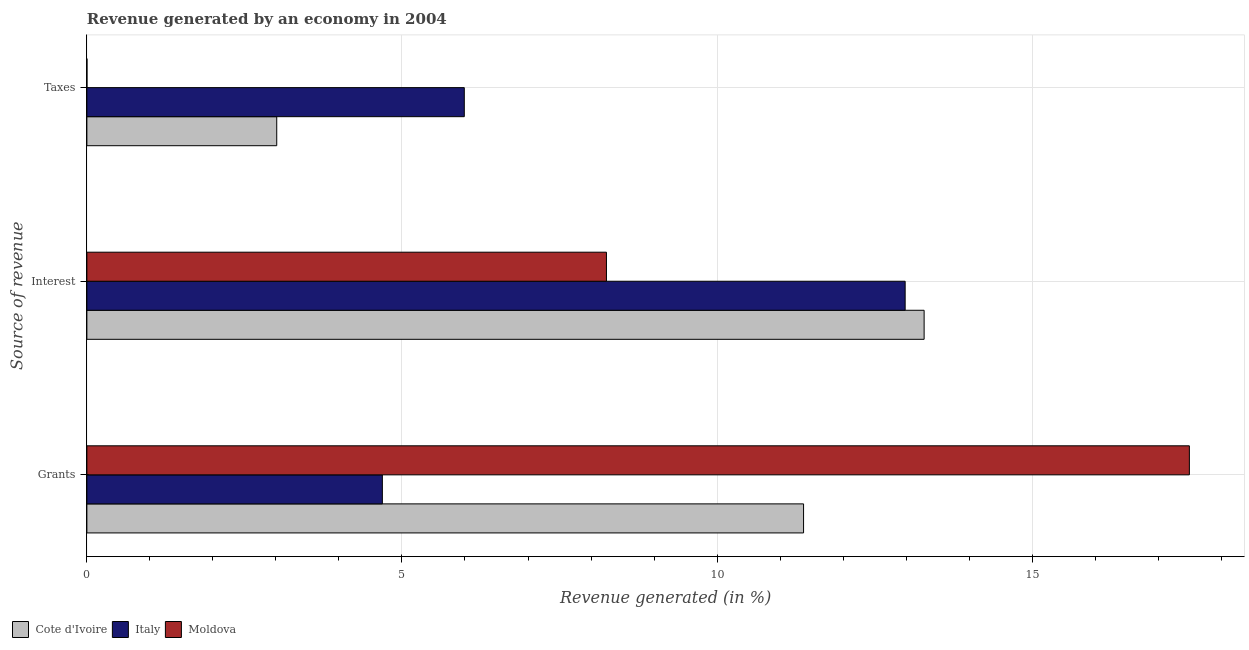How many groups of bars are there?
Your answer should be compact. 3. Are the number of bars per tick equal to the number of legend labels?
Offer a terse response. Yes. How many bars are there on the 2nd tick from the bottom?
Make the answer very short. 3. What is the label of the 1st group of bars from the top?
Your answer should be very brief. Taxes. What is the percentage of revenue generated by interest in Cote d'Ivoire?
Offer a very short reply. 13.29. Across all countries, what is the maximum percentage of revenue generated by interest?
Keep it short and to the point. 13.29. Across all countries, what is the minimum percentage of revenue generated by taxes?
Make the answer very short. 0. In which country was the percentage of revenue generated by grants maximum?
Offer a terse response. Moldova. What is the total percentage of revenue generated by taxes in the graph?
Give a very brief answer. 9. What is the difference between the percentage of revenue generated by interest in Moldova and that in Italy?
Ensure brevity in your answer.  -4.74. What is the difference between the percentage of revenue generated by interest in Moldova and the percentage of revenue generated by taxes in Italy?
Keep it short and to the point. 2.26. What is the average percentage of revenue generated by taxes per country?
Provide a succinct answer. 3. What is the difference between the percentage of revenue generated by grants and percentage of revenue generated by taxes in Moldova?
Offer a very short reply. 17.49. In how many countries, is the percentage of revenue generated by taxes greater than 9 %?
Ensure brevity in your answer.  0. What is the ratio of the percentage of revenue generated by taxes in Italy to that in Moldova?
Provide a short and direct response. 5612.84. Is the difference between the percentage of revenue generated by grants in Cote d'Ivoire and Moldova greater than the difference between the percentage of revenue generated by taxes in Cote d'Ivoire and Moldova?
Offer a very short reply. No. What is the difference between the highest and the second highest percentage of revenue generated by interest?
Your answer should be very brief. 0.3. What is the difference between the highest and the lowest percentage of revenue generated by interest?
Provide a short and direct response. 5.04. Is the sum of the percentage of revenue generated by taxes in Moldova and Cote d'Ivoire greater than the maximum percentage of revenue generated by grants across all countries?
Your response must be concise. No. What does the 2nd bar from the top in Interest represents?
Provide a succinct answer. Italy. What does the 3rd bar from the bottom in Grants represents?
Your answer should be very brief. Moldova. Is it the case that in every country, the sum of the percentage of revenue generated by grants and percentage of revenue generated by interest is greater than the percentage of revenue generated by taxes?
Ensure brevity in your answer.  Yes. How many bars are there?
Give a very brief answer. 9. What is the difference between two consecutive major ticks on the X-axis?
Give a very brief answer. 5. Are the values on the major ticks of X-axis written in scientific E-notation?
Make the answer very short. No. How many legend labels are there?
Make the answer very short. 3. What is the title of the graph?
Provide a short and direct response. Revenue generated by an economy in 2004. Does "Nicaragua" appear as one of the legend labels in the graph?
Your answer should be compact. No. What is the label or title of the X-axis?
Ensure brevity in your answer.  Revenue generated (in %). What is the label or title of the Y-axis?
Keep it short and to the point. Source of revenue. What is the Revenue generated (in %) in Cote d'Ivoire in Grants?
Your answer should be very brief. 11.37. What is the Revenue generated (in %) in Italy in Grants?
Ensure brevity in your answer.  4.69. What is the Revenue generated (in %) in Moldova in Grants?
Offer a terse response. 17.5. What is the Revenue generated (in %) in Cote d'Ivoire in Interest?
Your answer should be compact. 13.29. What is the Revenue generated (in %) in Italy in Interest?
Provide a short and direct response. 12.99. What is the Revenue generated (in %) of Moldova in Interest?
Offer a terse response. 8.25. What is the Revenue generated (in %) of Cote d'Ivoire in Taxes?
Keep it short and to the point. 3.01. What is the Revenue generated (in %) of Italy in Taxes?
Keep it short and to the point. 5.99. What is the Revenue generated (in %) of Moldova in Taxes?
Your response must be concise. 0. Across all Source of revenue, what is the maximum Revenue generated (in %) of Cote d'Ivoire?
Provide a short and direct response. 13.29. Across all Source of revenue, what is the maximum Revenue generated (in %) in Italy?
Give a very brief answer. 12.99. Across all Source of revenue, what is the maximum Revenue generated (in %) of Moldova?
Your answer should be compact. 17.5. Across all Source of revenue, what is the minimum Revenue generated (in %) in Cote d'Ivoire?
Offer a very short reply. 3.01. Across all Source of revenue, what is the minimum Revenue generated (in %) of Italy?
Offer a very short reply. 4.69. Across all Source of revenue, what is the minimum Revenue generated (in %) of Moldova?
Your answer should be very brief. 0. What is the total Revenue generated (in %) of Cote d'Ivoire in the graph?
Ensure brevity in your answer.  27.67. What is the total Revenue generated (in %) in Italy in the graph?
Your answer should be very brief. 23.66. What is the total Revenue generated (in %) of Moldova in the graph?
Your answer should be compact. 25.74. What is the difference between the Revenue generated (in %) in Cote d'Ivoire in Grants and that in Interest?
Give a very brief answer. -1.91. What is the difference between the Revenue generated (in %) of Italy in Grants and that in Interest?
Keep it short and to the point. -8.3. What is the difference between the Revenue generated (in %) of Moldova in Grants and that in Interest?
Make the answer very short. 9.25. What is the difference between the Revenue generated (in %) in Cote d'Ivoire in Grants and that in Taxes?
Provide a succinct answer. 8.36. What is the difference between the Revenue generated (in %) of Italy in Grants and that in Taxes?
Offer a very short reply. -1.3. What is the difference between the Revenue generated (in %) of Moldova in Grants and that in Taxes?
Your answer should be very brief. 17.49. What is the difference between the Revenue generated (in %) in Cote d'Ivoire in Interest and that in Taxes?
Offer a very short reply. 10.27. What is the difference between the Revenue generated (in %) in Italy in Interest and that in Taxes?
Make the answer very short. 7. What is the difference between the Revenue generated (in %) in Moldova in Interest and that in Taxes?
Your answer should be very brief. 8.24. What is the difference between the Revenue generated (in %) of Cote d'Ivoire in Grants and the Revenue generated (in %) of Italy in Interest?
Offer a terse response. -1.61. What is the difference between the Revenue generated (in %) of Cote d'Ivoire in Grants and the Revenue generated (in %) of Moldova in Interest?
Your answer should be compact. 3.13. What is the difference between the Revenue generated (in %) in Italy in Grants and the Revenue generated (in %) in Moldova in Interest?
Offer a very short reply. -3.56. What is the difference between the Revenue generated (in %) of Cote d'Ivoire in Grants and the Revenue generated (in %) of Italy in Taxes?
Make the answer very short. 5.38. What is the difference between the Revenue generated (in %) in Cote d'Ivoire in Grants and the Revenue generated (in %) in Moldova in Taxes?
Provide a short and direct response. 11.37. What is the difference between the Revenue generated (in %) of Italy in Grants and the Revenue generated (in %) of Moldova in Taxes?
Provide a short and direct response. 4.69. What is the difference between the Revenue generated (in %) of Cote d'Ivoire in Interest and the Revenue generated (in %) of Italy in Taxes?
Provide a short and direct response. 7.3. What is the difference between the Revenue generated (in %) of Cote d'Ivoire in Interest and the Revenue generated (in %) of Moldova in Taxes?
Offer a terse response. 13.29. What is the difference between the Revenue generated (in %) of Italy in Interest and the Revenue generated (in %) of Moldova in Taxes?
Give a very brief answer. 12.98. What is the average Revenue generated (in %) of Cote d'Ivoire per Source of revenue?
Your answer should be very brief. 9.22. What is the average Revenue generated (in %) in Italy per Source of revenue?
Your response must be concise. 7.89. What is the average Revenue generated (in %) of Moldova per Source of revenue?
Provide a short and direct response. 8.58. What is the difference between the Revenue generated (in %) in Cote d'Ivoire and Revenue generated (in %) in Italy in Grants?
Your answer should be very brief. 6.68. What is the difference between the Revenue generated (in %) of Cote d'Ivoire and Revenue generated (in %) of Moldova in Grants?
Offer a terse response. -6.12. What is the difference between the Revenue generated (in %) of Italy and Revenue generated (in %) of Moldova in Grants?
Offer a terse response. -12.81. What is the difference between the Revenue generated (in %) in Cote d'Ivoire and Revenue generated (in %) in Italy in Interest?
Give a very brief answer. 0.3. What is the difference between the Revenue generated (in %) in Cote d'Ivoire and Revenue generated (in %) in Moldova in Interest?
Give a very brief answer. 5.04. What is the difference between the Revenue generated (in %) of Italy and Revenue generated (in %) of Moldova in Interest?
Keep it short and to the point. 4.74. What is the difference between the Revenue generated (in %) of Cote d'Ivoire and Revenue generated (in %) of Italy in Taxes?
Keep it short and to the point. -2.98. What is the difference between the Revenue generated (in %) in Cote d'Ivoire and Revenue generated (in %) in Moldova in Taxes?
Your answer should be very brief. 3.01. What is the difference between the Revenue generated (in %) in Italy and Revenue generated (in %) in Moldova in Taxes?
Ensure brevity in your answer.  5.99. What is the ratio of the Revenue generated (in %) in Cote d'Ivoire in Grants to that in Interest?
Keep it short and to the point. 0.86. What is the ratio of the Revenue generated (in %) in Italy in Grants to that in Interest?
Offer a terse response. 0.36. What is the ratio of the Revenue generated (in %) of Moldova in Grants to that in Interest?
Ensure brevity in your answer.  2.12. What is the ratio of the Revenue generated (in %) in Cote d'Ivoire in Grants to that in Taxes?
Your answer should be compact. 3.77. What is the ratio of the Revenue generated (in %) of Italy in Grants to that in Taxes?
Your response must be concise. 0.78. What is the ratio of the Revenue generated (in %) of Moldova in Grants to that in Taxes?
Provide a succinct answer. 1.64e+04. What is the ratio of the Revenue generated (in %) in Cote d'Ivoire in Interest to that in Taxes?
Offer a very short reply. 4.41. What is the ratio of the Revenue generated (in %) in Italy in Interest to that in Taxes?
Your response must be concise. 2.17. What is the ratio of the Revenue generated (in %) of Moldova in Interest to that in Taxes?
Provide a short and direct response. 7727. What is the difference between the highest and the second highest Revenue generated (in %) of Cote d'Ivoire?
Provide a short and direct response. 1.91. What is the difference between the highest and the second highest Revenue generated (in %) in Italy?
Ensure brevity in your answer.  7. What is the difference between the highest and the second highest Revenue generated (in %) of Moldova?
Provide a short and direct response. 9.25. What is the difference between the highest and the lowest Revenue generated (in %) in Cote d'Ivoire?
Your answer should be very brief. 10.27. What is the difference between the highest and the lowest Revenue generated (in %) of Italy?
Offer a terse response. 8.3. What is the difference between the highest and the lowest Revenue generated (in %) of Moldova?
Provide a succinct answer. 17.49. 